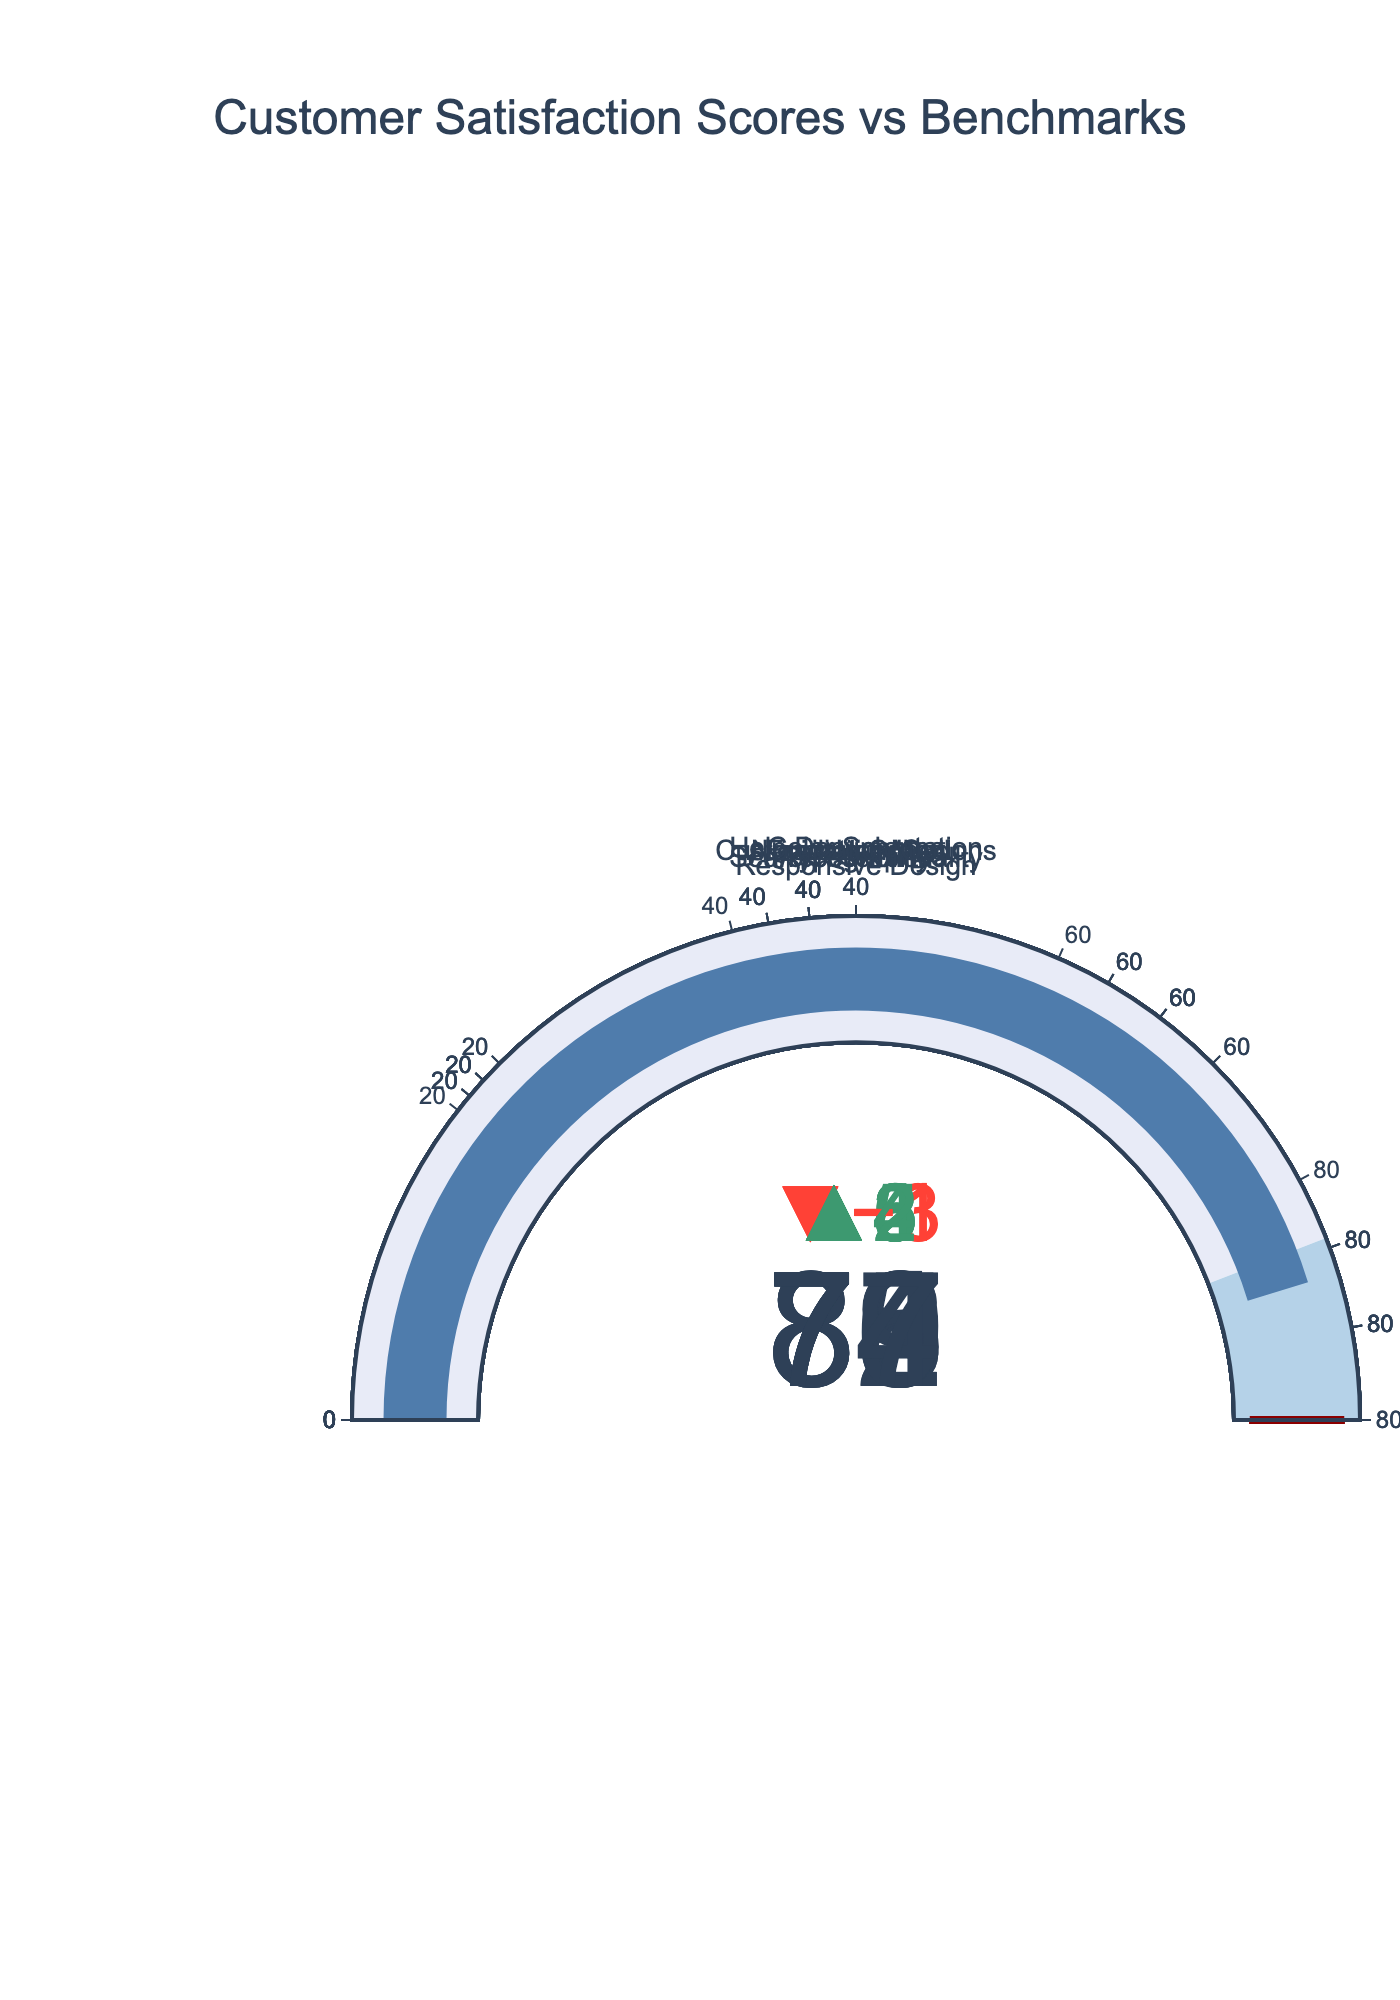What is the title of the chart? The title is usually located at the top of the chart. It is meant to provide an overview of what the chart represents. By looking at the top of the chart, the title displayed is "Customer Satisfaction Scores vs Benchmarks".
Answer: Customer Satisfaction Scores vs Benchmarks How many features are represented in the chart? The chart visualizes the scores of various features. Each individual bullet graph corresponds to one feature. By counting the distinct bullet graphs, we see there are 10 features represented.
Answer: 10 What feature has the highest actual score? To identify the feature with the highest actual score, one would look at the value displayed within each bullet graph. The highest value is observed in the "Responsive Design" feature, which has an actual score of 88.
Answer: Responsive Design Which feature's actual score is the furthest below its target? To determine this, for each feature, subtract the actual score from the target score and find the maximum difference that is negative. The largest discrepancy is observed in "Responsive Design", where the actual score is 88 and the target is 95, resulting in a 7-point deficit.
Answer: Responsive Design Which feature's actual score is the closest to its target? By examining the differences between the actual scores and target scores for each feature and finding the smallest positive difference, we see "Color Scheme" has an actual score of 76 and a target of 80, resulting in a 4-point difference, which is the closest.
Answer: Color Scheme What colors are used to represent the range between current scores and benchmarks? The chart uses colors to visually indicate ranges, with different colors representing the segments. The range from 0 to the benchmark is shown in light blue, and the range from the benchmark to the target is shown in a darker blue.
Answer: Light blue and dark blue Which feature meets or exceeds its benchmark but not its target? By comparing the actual scores with benchmarks and targets for each feature, we find "Search Functionality" (actual score 82, benchmark 80, target 90) meets this condition, as its actual score exceeds the benchmark but not the target.
Answer: Search Functionality Which features have an actual score below their benchmark? To find this, compare the actual scores to benchmarks for each feature. Features with actual scores below their benchmarks are "Loading Speed" and "Accessibility", with respective scores below their benchmarks of 72 < 75 and 79 < 80.
Answer: Loading Speed and Accessibility Calculate the average of the actual scores across all features. Sum all the actual scores and divide by the number of features. The sum is 78 + 82 + 88 + 76 + 85 + 72 + 80 + 79 + 74 + 77 = 791. Dividing by 10 features gives an average of 791 / 10 = 79.1.
Answer: 79.1 